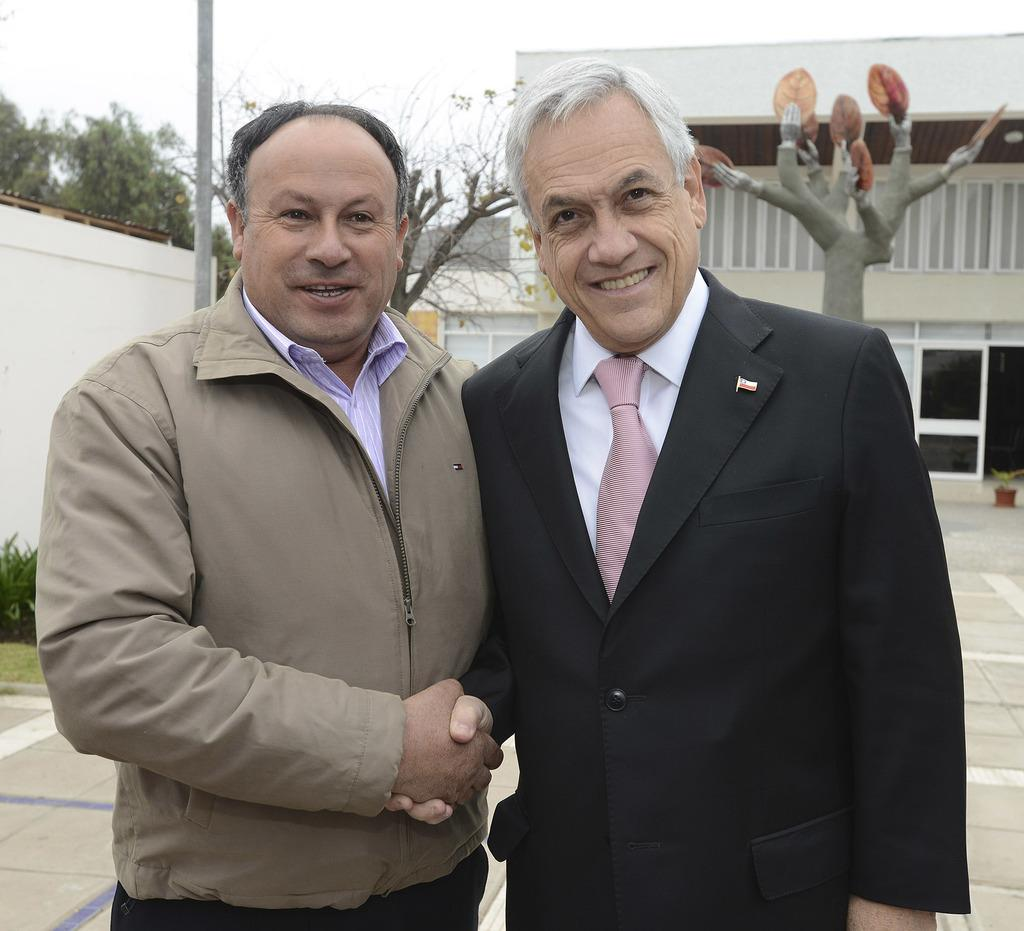How many people are present in the image? There are two men standing in the image. What can be seen in the background of the image? There are trees and buildings visible in the background of the image. What type of design can be seen on the cabbage in the image? There is no cabbage present in the image, so it is not possible to answer that question. 